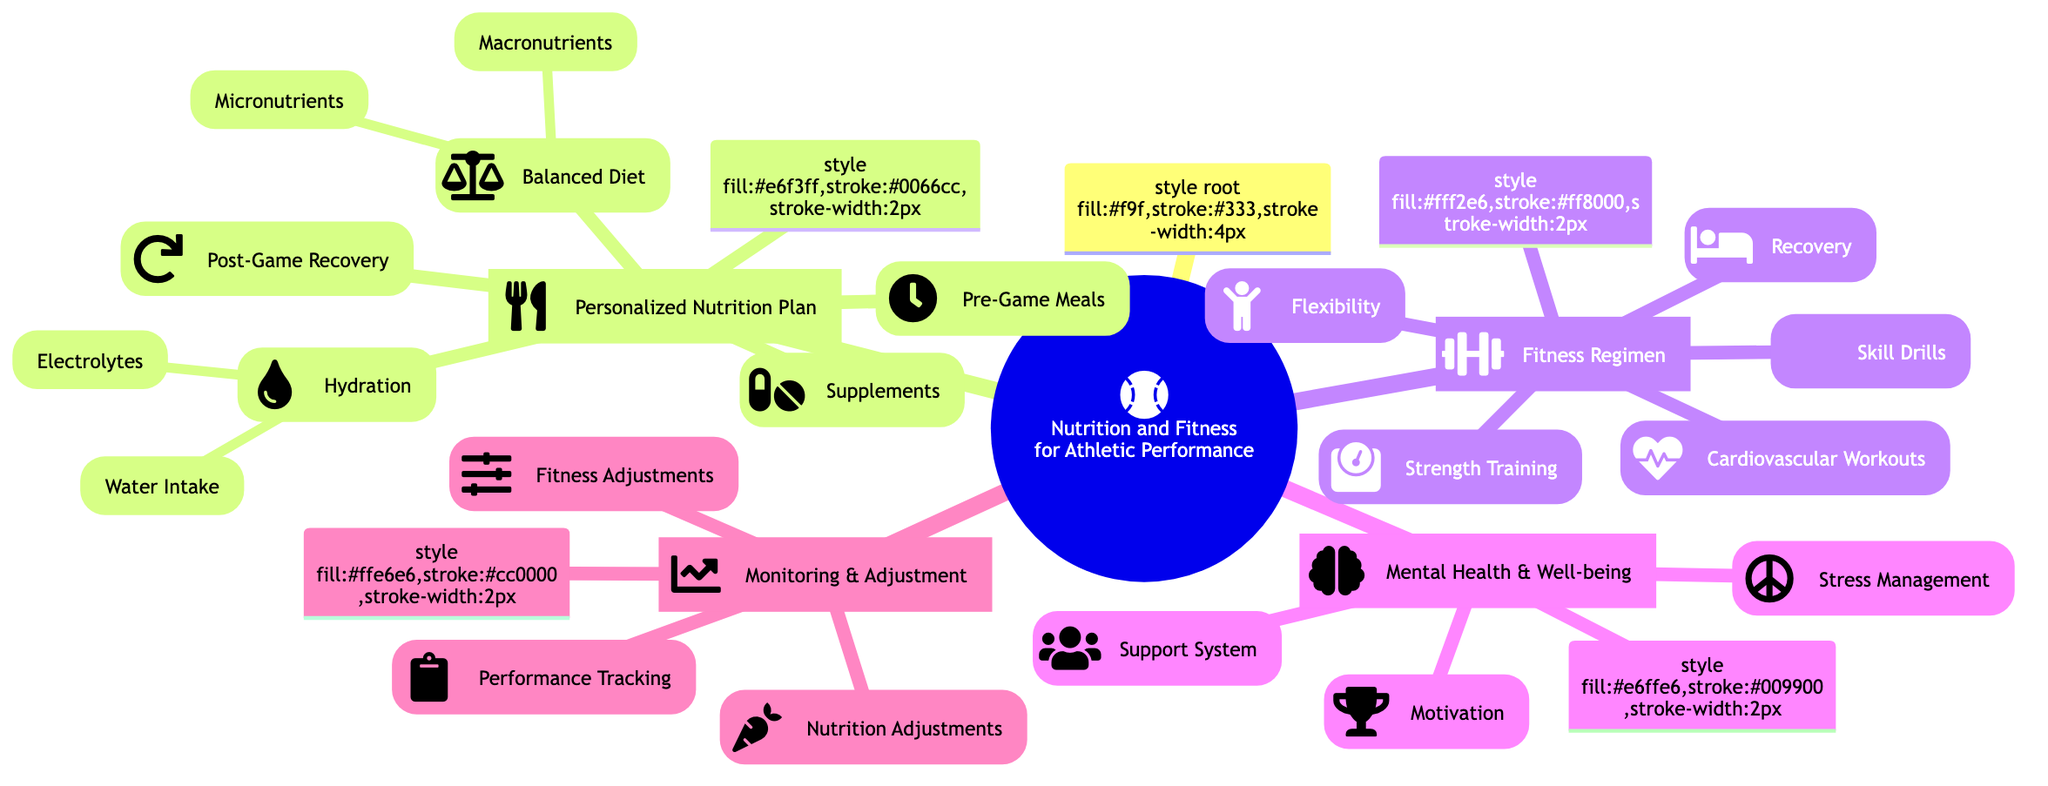What are the two main components of the Personalized Nutrition Plan? The two main components are "Nutrition" and "Fitness Regimen," as seen in the first two major branches stemming from the root node in the diagram.
Answer: Nutrition and Fitness Regimen How many categories are listed under Monitoring & Adjustment? There are three categories listed under Monitoring & Adjustment: "Performance Tracking," "Nutrition Adjustments," and "Fitness Adjustments." This is determined by counting the nodes directly connected to the Monitoring & Adjustment node.
Answer: Three What type of workouts are included in the Fitness Regimen? The Fitness Regimen includes "Strength Training," "Cardiovascular Workouts," "Flexibility," "Skill Drills," and "Recovery," which are all explicitly mentioned as sub-nodes under Fitness Regimen in the mind map.
Answer: Strength Training, Cardiovascular Workouts, Flexibility, Skill Drills, Recovery What is one key focus of Mental Health & Well-being in the diagram? One key focus is "Stress Management," as it is prominently listed as one of the sub-categories under Mental Health & Well-being in the diagram.
Answer: Stress Management Which sub-node under Personalized Nutrition Plan emphasizes hydration? The sub-node that emphasizes hydration is "Hydration," which further branches out to specific aspects like "Water Intake" and "Electrolytes," clearly indicating its importance within the diagram.
Answer: Hydration What is the purpose of the Support System in Mental Health & Well-being? The Support System, which includes "Coach Guidance" and "Family Support," is intended to provide emotional and motivational support for athletes, as highlighted under Mental Health & Well-being.
Answer: Emotional and motivational support How many specific elements are there under Supplements? There are three specific supplements listed: "Creatine," "BCAAs," and "Multivitamins," as shown directly connected to the Supplements node in the diagram.
Answer: Three How does Performance Tracking relate to Monitoring & Adjustment? Performance Tracking is a sub-node under Monitoring & Adjustment, indicating that it is a part of the broader process of monitoring and adjusting both nutrition and fitness plans in the context of athletic performance.
Answer: It’s a sub-node; part of Monitoring & Adjustment What are some examples of Skill Drills listed in the diagram? The examples of Skill Drills mentioned are "Batting Practice," "Fielding Drills," and "Base Running," all of which are explicitly stated under the Skill Drills node in the mind map.
Answer: Batting Practice, Fielding Drills, Base Running 